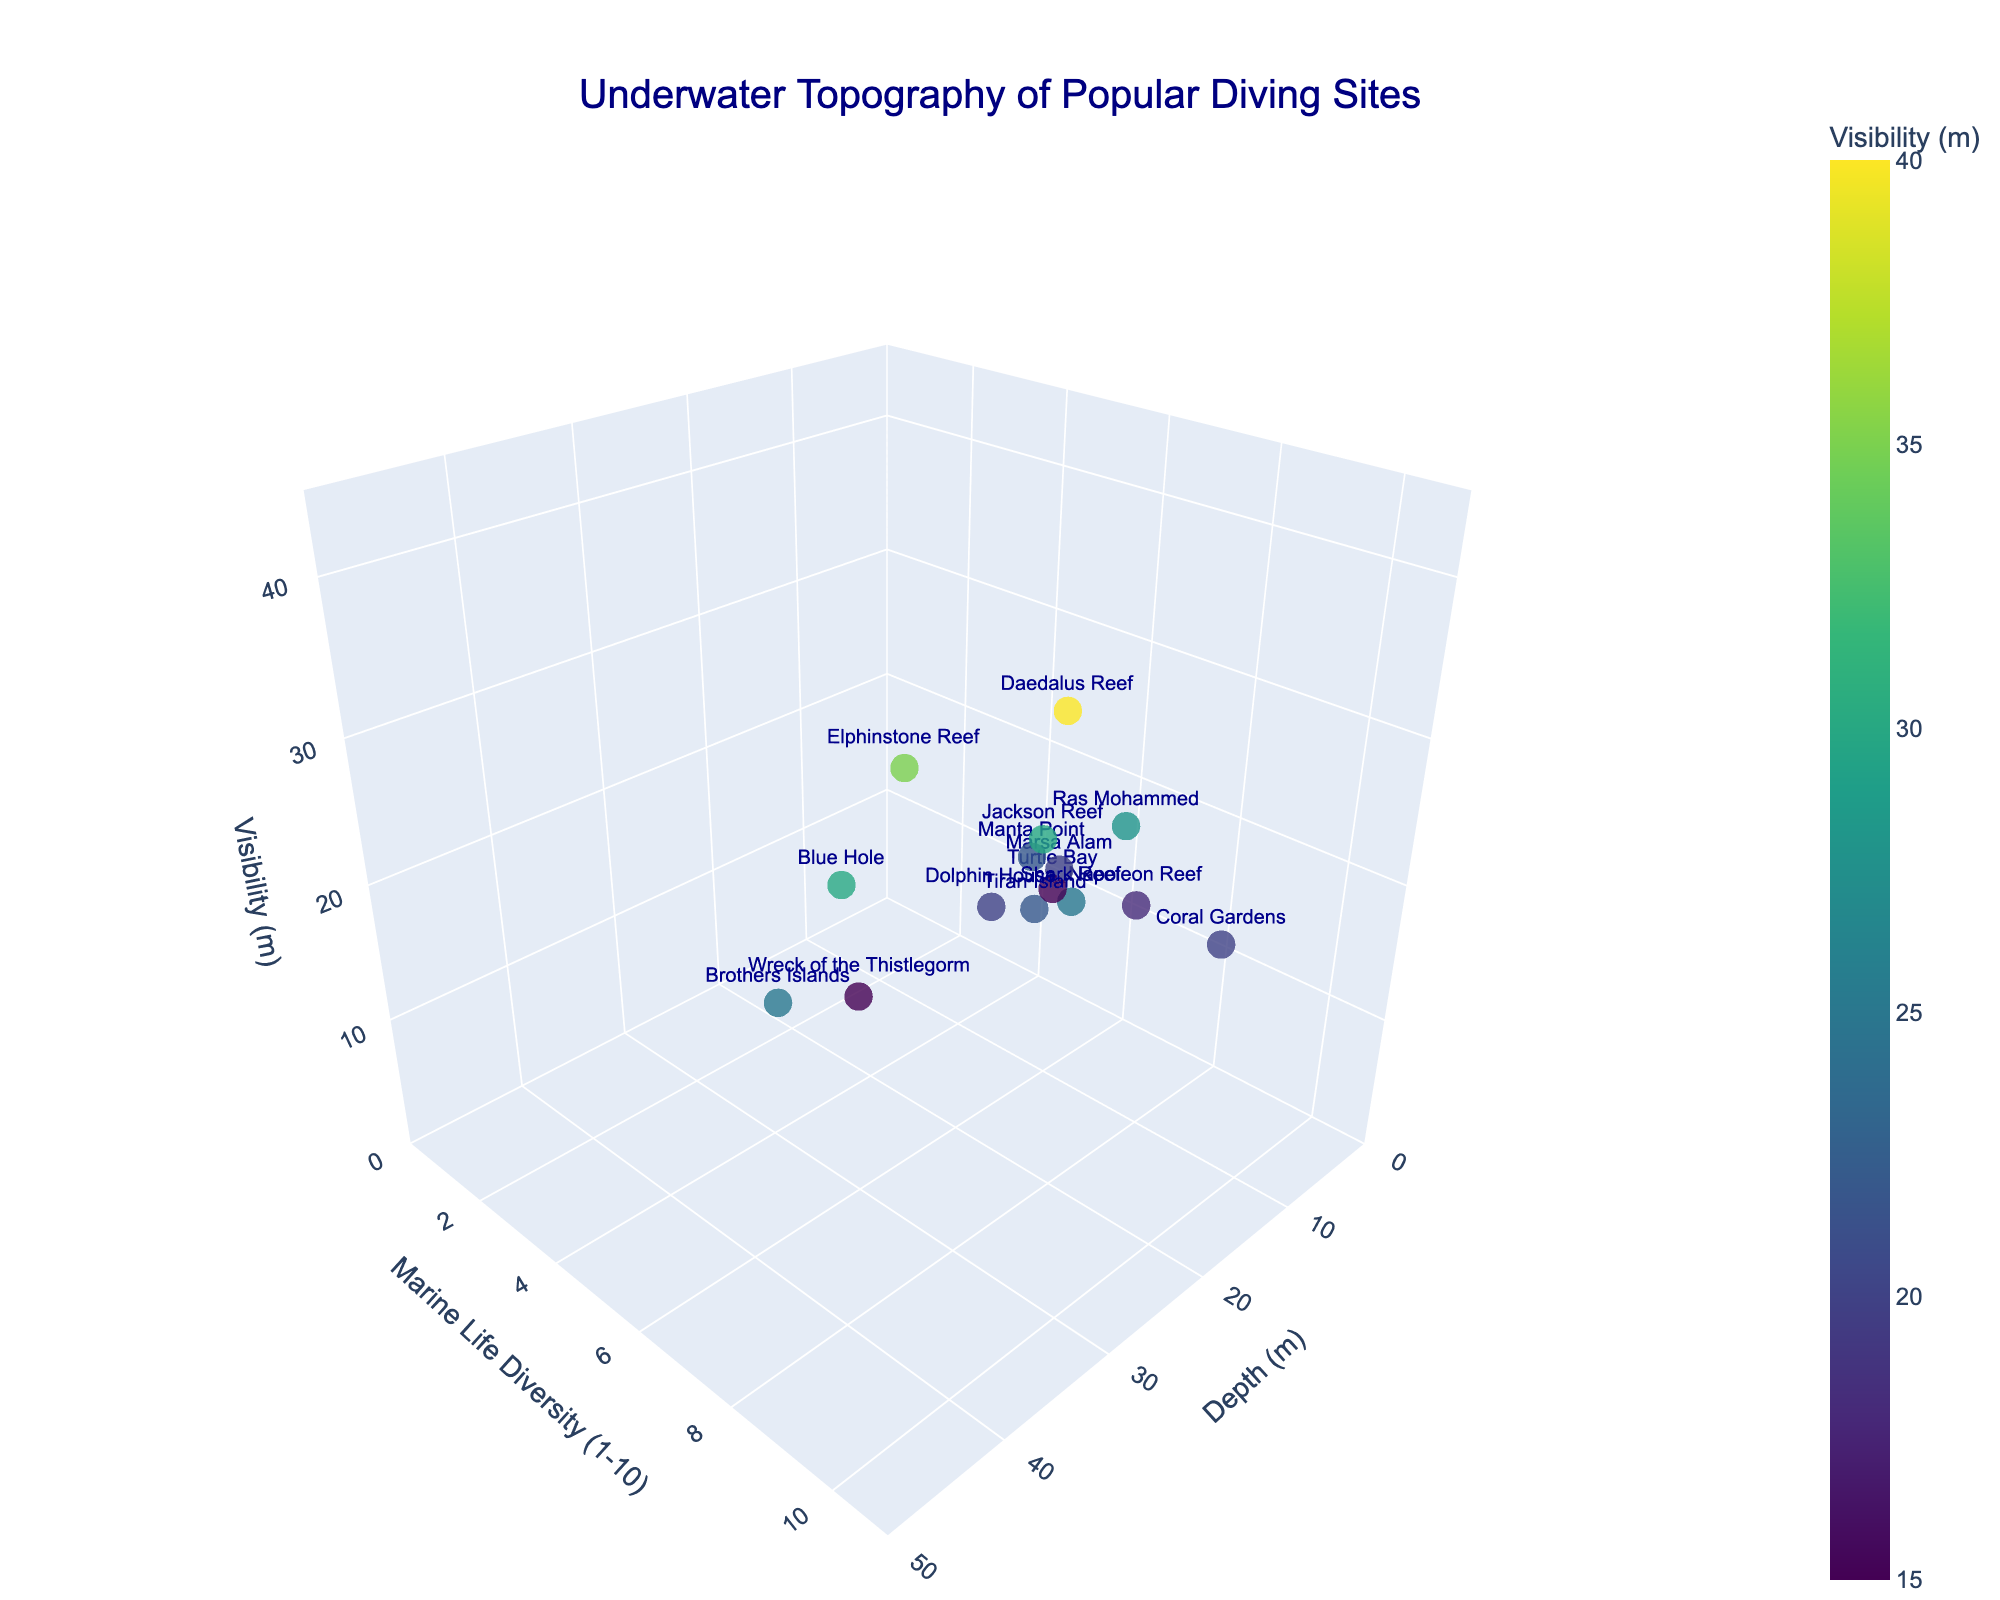What is the title of the plot? The title of the plot is usually found at the top center and typically provides a summary of what the plot is about. Looking at the figure, you can see that the title reads "Underwater Topography of Popular Diving Sites."
Answer: Underwater Topography of Popular Diving Sites What are the axes labels of the plot? The axes labels describe what each dimension represents in the 3D plot. The x-axis is labeled 'Depth (m)', the y-axis is labeled 'Marine Life Diversity (1-10)', and the z-axis is labeled 'Visibility (m)'.
Answer: Depth (m), Marine Life Diversity (1-10), Visibility (m) How many diving sites are represented in the plot? Each marker represents one diving site. Counting all markers in the plot will give you the total number of diving sites shown. There are 15 markers in total.
Answer: 15 Which diving site has the highest depth? To find the diving site with the highest depth, look for the marker with the largest value on the x-axis. The site "Brothers Islands" has the highest depth of 45 meters.
Answer: Brothers Islands Which site has the best visibility? The best visibility is represented by the highest value on the z-axis. In this plot, "Daedalus Reef" has the best visibility at 40 meters.
Answer: Daedalus Reef What is the approximate average marine life diversity score across all sites? To find the average marine life diversity score, sum all diversity scores and divide by the number of sites. The scores are 8, 9, 10, 7, 6, 8, 9, 7, 8, 9, 10, 8, 7, 8, 6. Their sum is 124. Divided by 15 sites, the average is approximately 124/15 ≈ 8.27.
Answer: 8.27 Which site offers the shallowest diving experience? The site with the smallest value on the x-axis offers the shallowest diving experience. "Turtle Bay" offers the shallowest experience at 10 meters.
Answer: Turtle Bay Compare the marine life diversity between "Coral Gardens" and "Shark Reef". Which one is higher? Find the respective markers for "Coral Gardens" and "Shark Reef" and compare their y-axis values. "Coral Gardens" has a score of 10 and "Shark Reef" has a score of 9. Therefore, Coral Gardens has higher marine life diversity.
Answer: Coral Gardens What site has the combination of high marine life diversity (greater than 8) and high visibility (greater than 30)? Look for sites where the y-axis value is greater than 8 and the z-axis value is greater than 30. "Daedalus Reef" fits this criterion with a marine life diversity score of 10 and visibility of 40 meters.
Answer: Daedalus Reef Which sites have both visibility and marine life diversity scores below 20 and 7 respectively? Identify points where the value along the z-axis (visibility) is below 20 and the y-axis (marine life diversity) is below 7. "Wreck of the Thistlegorm" and "Turtle Bay" meet these criteria with respective scores of (15 meters, 6) and (15 meters, 6).
Answer: Wreck of the Thistlegorm, Turtle Bay 